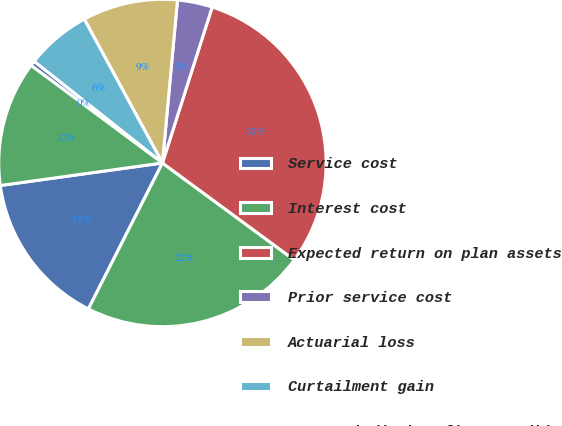Convert chart. <chart><loc_0><loc_0><loc_500><loc_500><pie_chart><fcel>Service cost<fcel>Interest cost<fcel>Expected return on plan assets<fcel>Prior service cost<fcel>Actuarial loss<fcel>Curtailment gain<fcel>Net periodic benefit cost (b)<fcel>Net periodic benefit cost (c)<nl><fcel>15.33%<fcel>22.38%<fcel>30.17%<fcel>3.45%<fcel>9.39%<fcel>6.42%<fcel>0.49%<fcel>12.36%<nl></chart> 